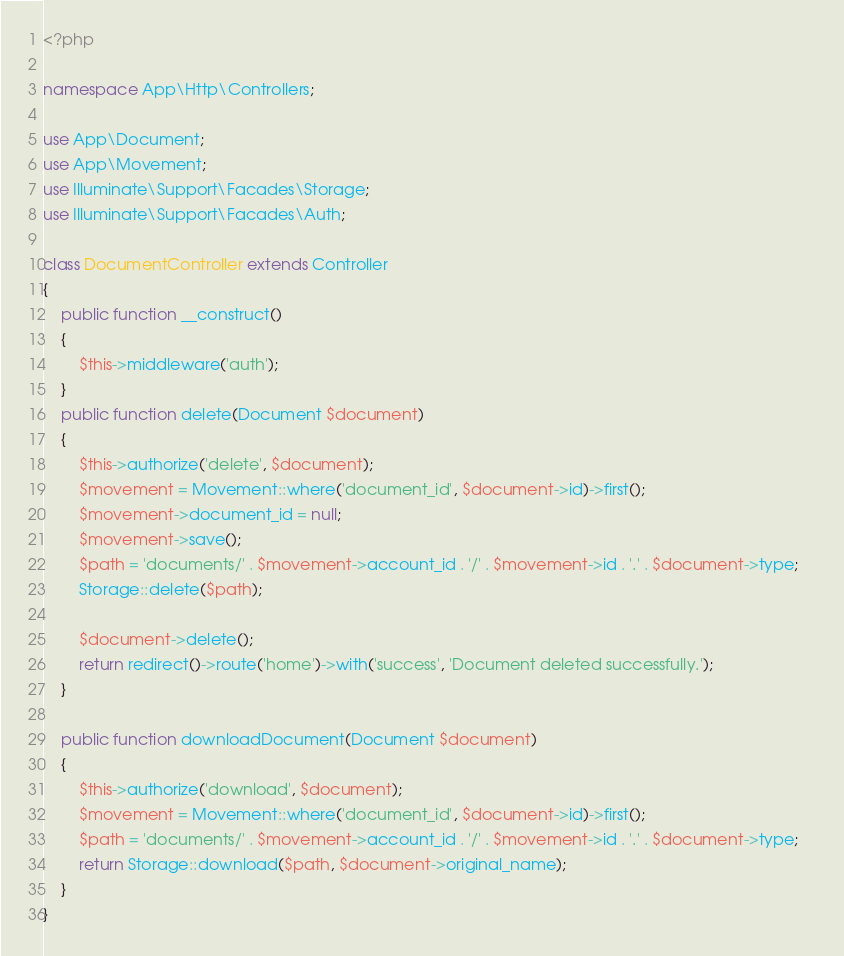Convert code to text. <code><loc_0><loc_0><loc_500><loc_500><_PHP_><?php

namespace App\Http\Controllers;

use App\Document;
use App\Movement;
use Illuminate\Support\Facades\Storage;
use Illuminate\Support\Facades\Auth;

class DocumentController extends Controller
{
    public function __construct()
    {
        $this->middleware('auth');
    }
    public function delete(Document $document)
    {
        $this->authorize('delete', $document);
        $movement = Movement::where('document_id', $document->id)->first();
        $movement->document_id = null;
        $movement->save();
        $path = 'documents/' . $movement->account_id . '/' . $movement->id . '.' . $document->type;
        Storage::delete($path);

        $document->delete();
        return redirect()->route('home')->with('success', 'Document deleted successfully.');
    }

    public function downloadDocument(Document $document)
    {
        $this->authorize('download', $document);
        $movement = Movement::where('document_id', $document->id)->first();
        $path = 'documents/' . $movement->account_id . '/' . $movement->id . '.' . $document->type;    
        return Storage::download($path, $document->original_name);
    }
}
</code> 